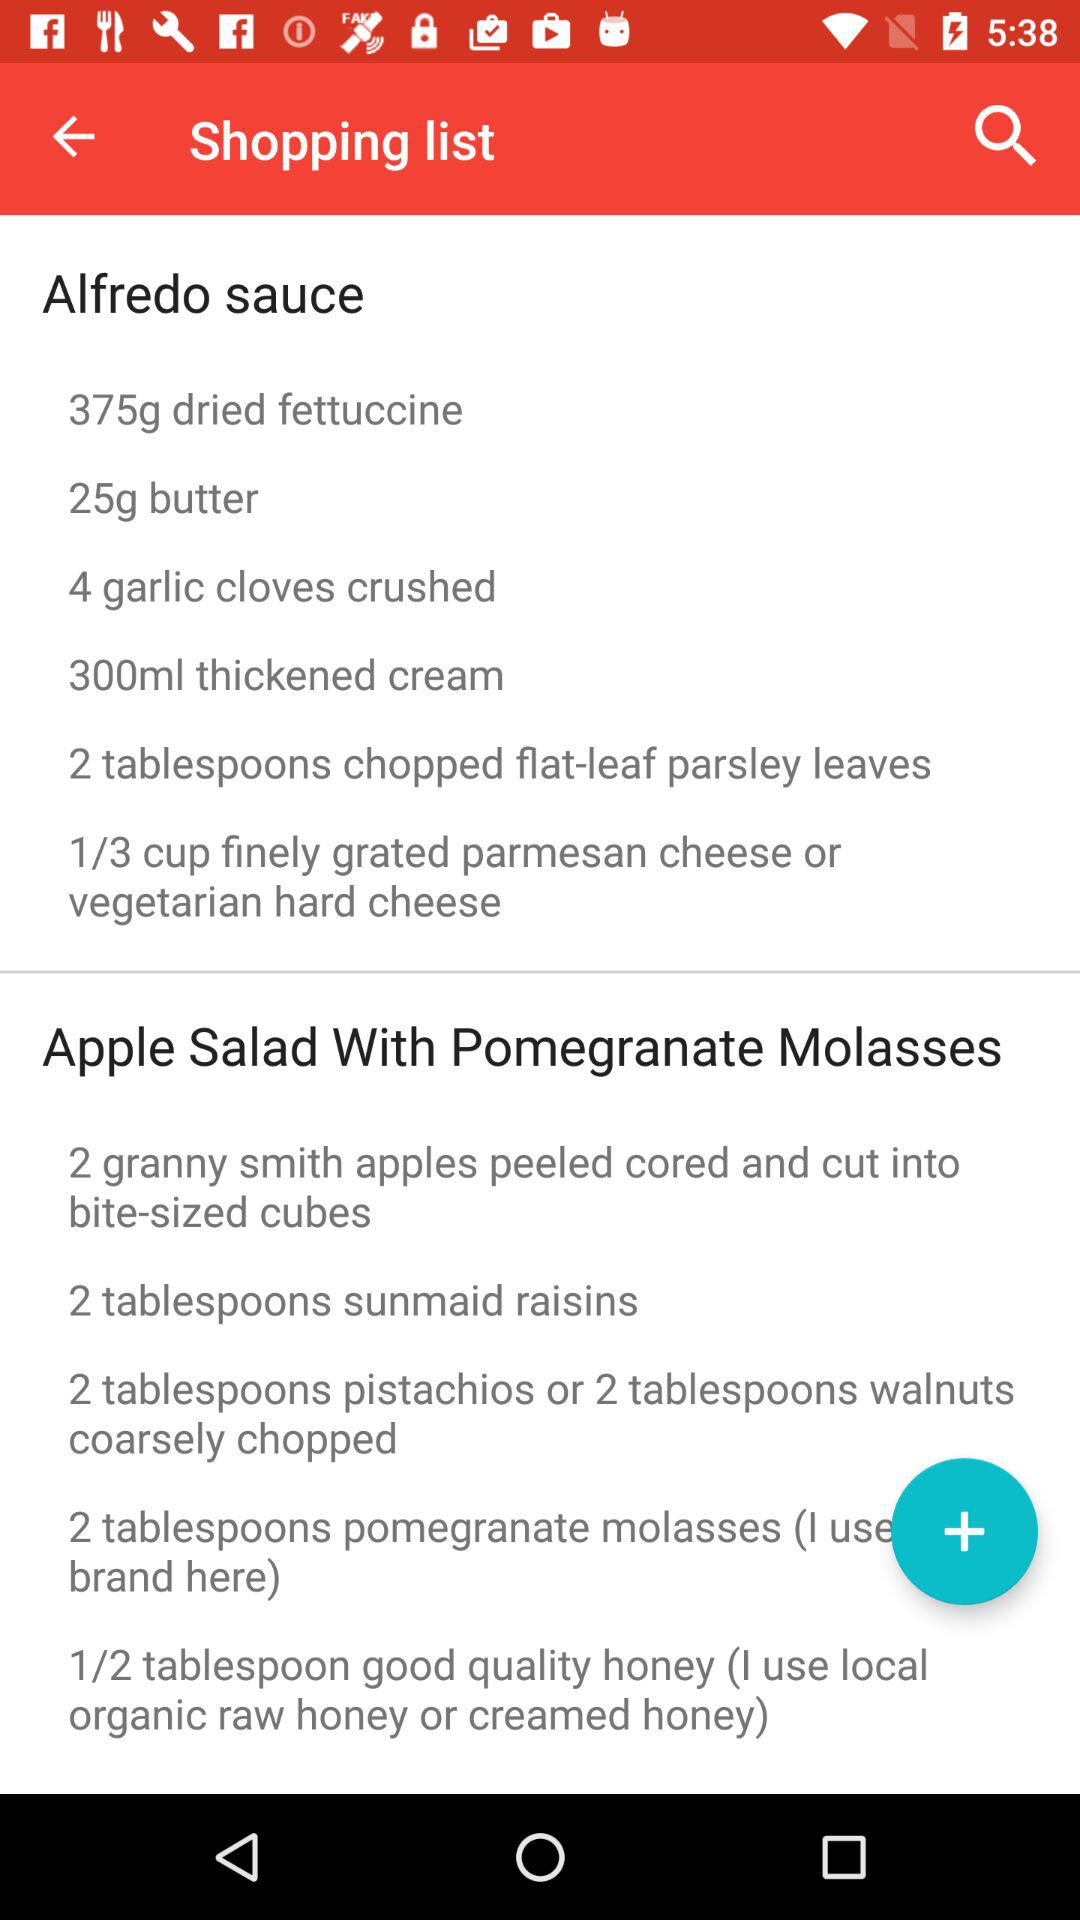What are the dishes given? The dishes are "Alfredo sauce" and "Apple Salad With Pomegranate Molasses". 